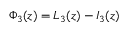Convert formula to latex. <formula><loc_0><loc_0><loc_500><loc_500>\Phi _ { 3 } ( z ) = L _ { 3 } ( z ) - I _ { 3 } ( z )</formula> 